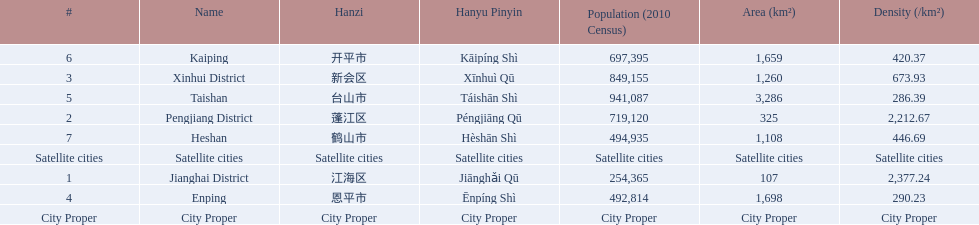What are the satellite cities of jiangmen? Enping, Taishan, Kaiping, Heshan. Of these cities, which has the highest density? Taishan. 